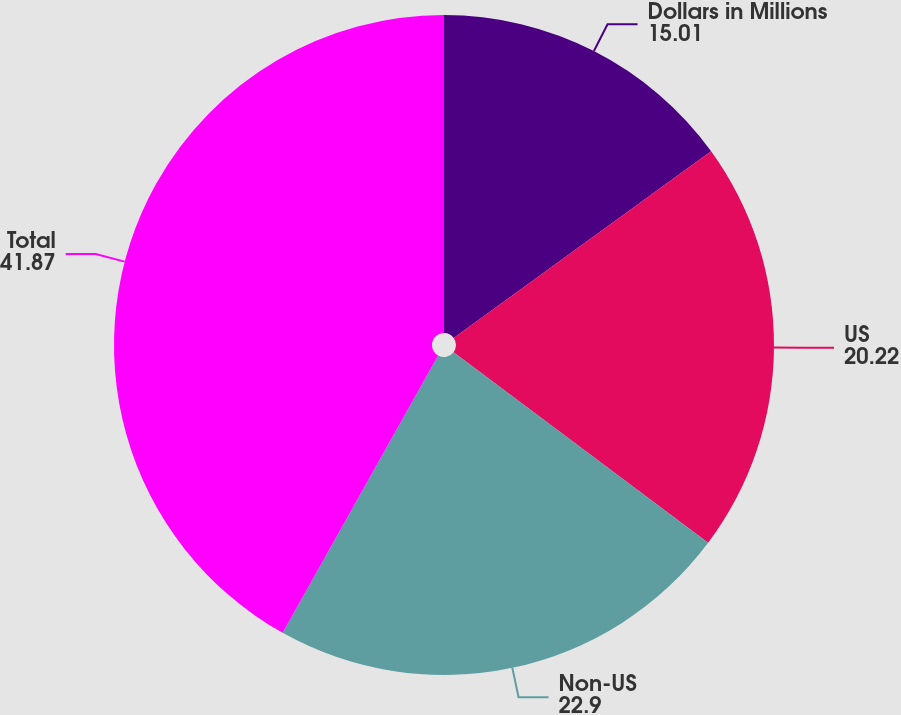Convert chart to OTSL. <chart><loc_0><loc_0><loc_500><loc_500><pie_chart><fcel>Dollars in Millions<fcel>US<fcel>Non-US<fcel>Total<nl><fcel>15.01%<fcel>20.22%<fcel>22.9%<fcel>41.87%<nl></chart> 